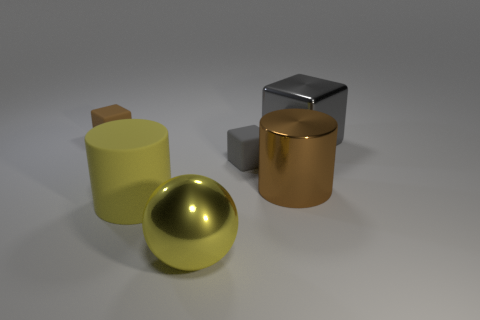What size is the yellow cylinder? The yellow cylinder appears to be medium-sized in comparison to the other objects in the scene. Its height seems to be roughly equivalent to the diameter of the yellow sphere next to it. 